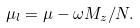<formula> <loc_0><loc_0><loc_500><loc_500>\mu _ { l } = \mu - \omega M _ { z } / N .</formula> 